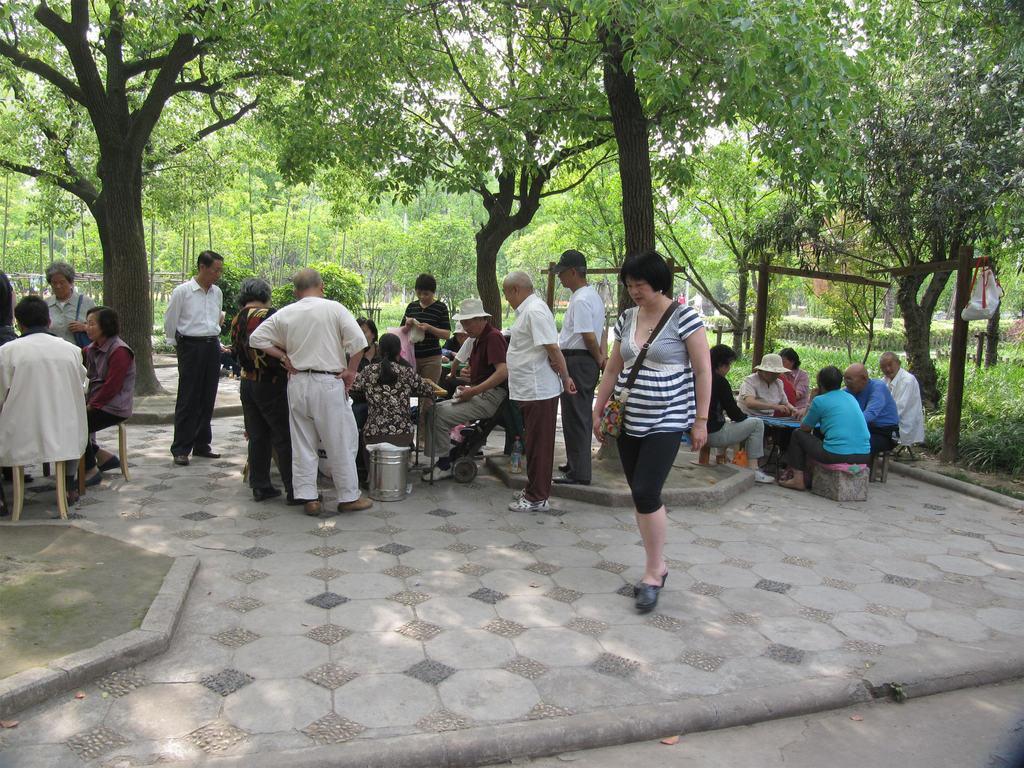Can you describe this image briefly? In this picture there are people, among them few people sitting and we can see chairs and tables. We can see plants, trees, bag and wooden poles. In the background of the image we can see the sky. 